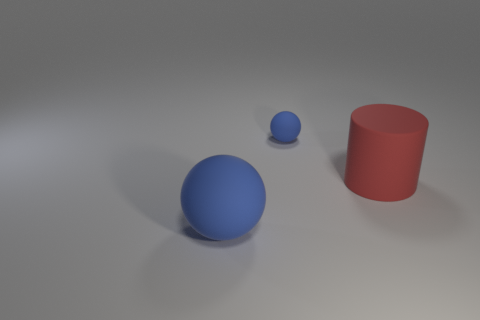Is the large red cylinder made of the same material as the blue thing that is left of the small blue rubber thing?
Make the answer very short. Yes. There is a rubber thing that is on the right side of the sphere behind the red cylinder; what shape is it?
Offer a very short reply. Cylinder. There is a large cylinder; is its color the same as the ball left of the small ball?
Ensure brevity in your answer.  No. What is the shape of the large red object?
Keep it short and to the point. Cylinder. There is a rubber cylinder in front of the blue matte thing that is behind the large blue object; what is its size?
Provide a short and direct response. Large. Are there the same number of blue objects that are to the left of the big matte sphere and red matte cylinders in front of the large red matte cylinder?
Offer a terse response. Yes. What material is the thing that is both behind the large matte ball and in front of the tiny blue object?
Make the answer very short. Rubber. Is the size of the red matte object the same as the blue ball that is behind the red thing?
Give a very brief answer. No. How many other things are there of the same color as the big rubber ball?
Your response must be concise. 1. Are there more matte objects behind the red object than big purple rubber objects?
Give a very brief answer. Yes. 